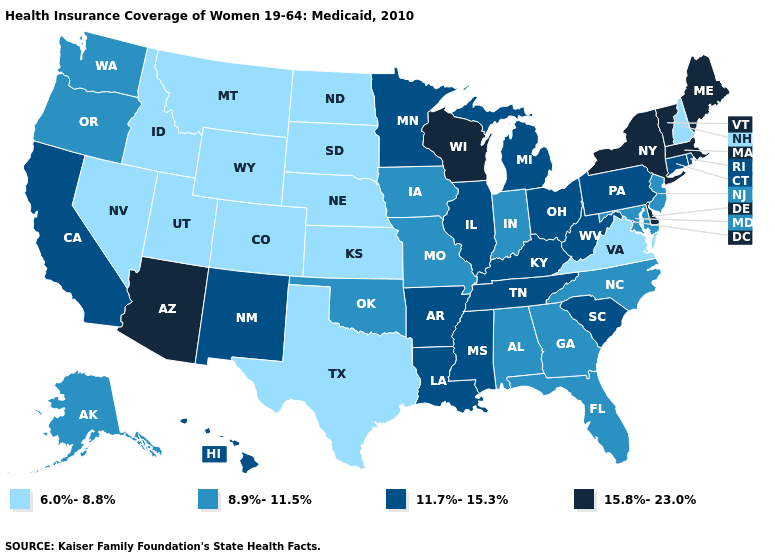Name the states that have a value in the range 11.7%-15.3%?
Keep it brief. Arkansas, California, Connecticut, Hawaii, Illinois, Kentucky, Louisiana, Michigan, Minnesota, Mississippi, New Mexico, Ohio, Pennsylvania, Rhode Island, South Carolina, Tennessee, West Virginia. Name the states that have a value in the range 8.9%-11.5%?
Short answer required. Alabama, Alaska, Florida, Georgia, Indiana, Iowa, Maryland, Missouri, New Jersey, North Carolina, Oklahoma, Oregon, Washington. Name the states that have a value in the range 15.8%-23.0%?
Answer briefly. Arizona, Delaware, Maine, Massachusetts, New York, Vermont, Wisconsin. Name the states that have a value in the range 15.8%-23.0%?
Be succinct. Arizona, Delaware, Maine, Massachusetts, New York, Vermont, Wisconsin. Name the states that have a value in the range 15.8%-23.0%?
Be succinct. Arizona, Delaware, Maine, Massachusetts, New York, Vermont, Wisconsin. Among the states that border North Dakota , which have the lowest value?
Short answer required. Montana, South Dakota. Does New Hampshire have the lowest value in the Northeast?
Concise answer only. Yes. What is the lowest value in the West?
Be succinct. 6.0%-8.8%. Name the states that have a value in the range 6.0%-8.8%?
Keep it brief. Colorado, Idaho, Kansas, Montana, Nebraska, Nevada, New Hampshire, North Dakota, South Dakota, Texas, Utah, Virginia, Wyoming. Which states hav the highest value in the MidWest?
Write a very short answer. Wisconsin. Does Oklahoma have the lowest value in the South?
Quick response, please. No. How many symbols are there in the legend?
Give a very brief answer. 4. Does California have the highest value in the USA?
Quick response, please. No. Which states have the highest value in the USA?
Quick response, please. Arizona, Delaware, Maine, Massachusetts, New York, Vermont, Wisconsin. Name the states that have a value in the range 6.0%-8.8%?
Write a very short answer. Colorado, Idaho, Kansas, Montana, Nebraska, Nevada, New Hampshire, North Dakota, South Dakota, Texas, Utah, Virginia, Wyoming. 